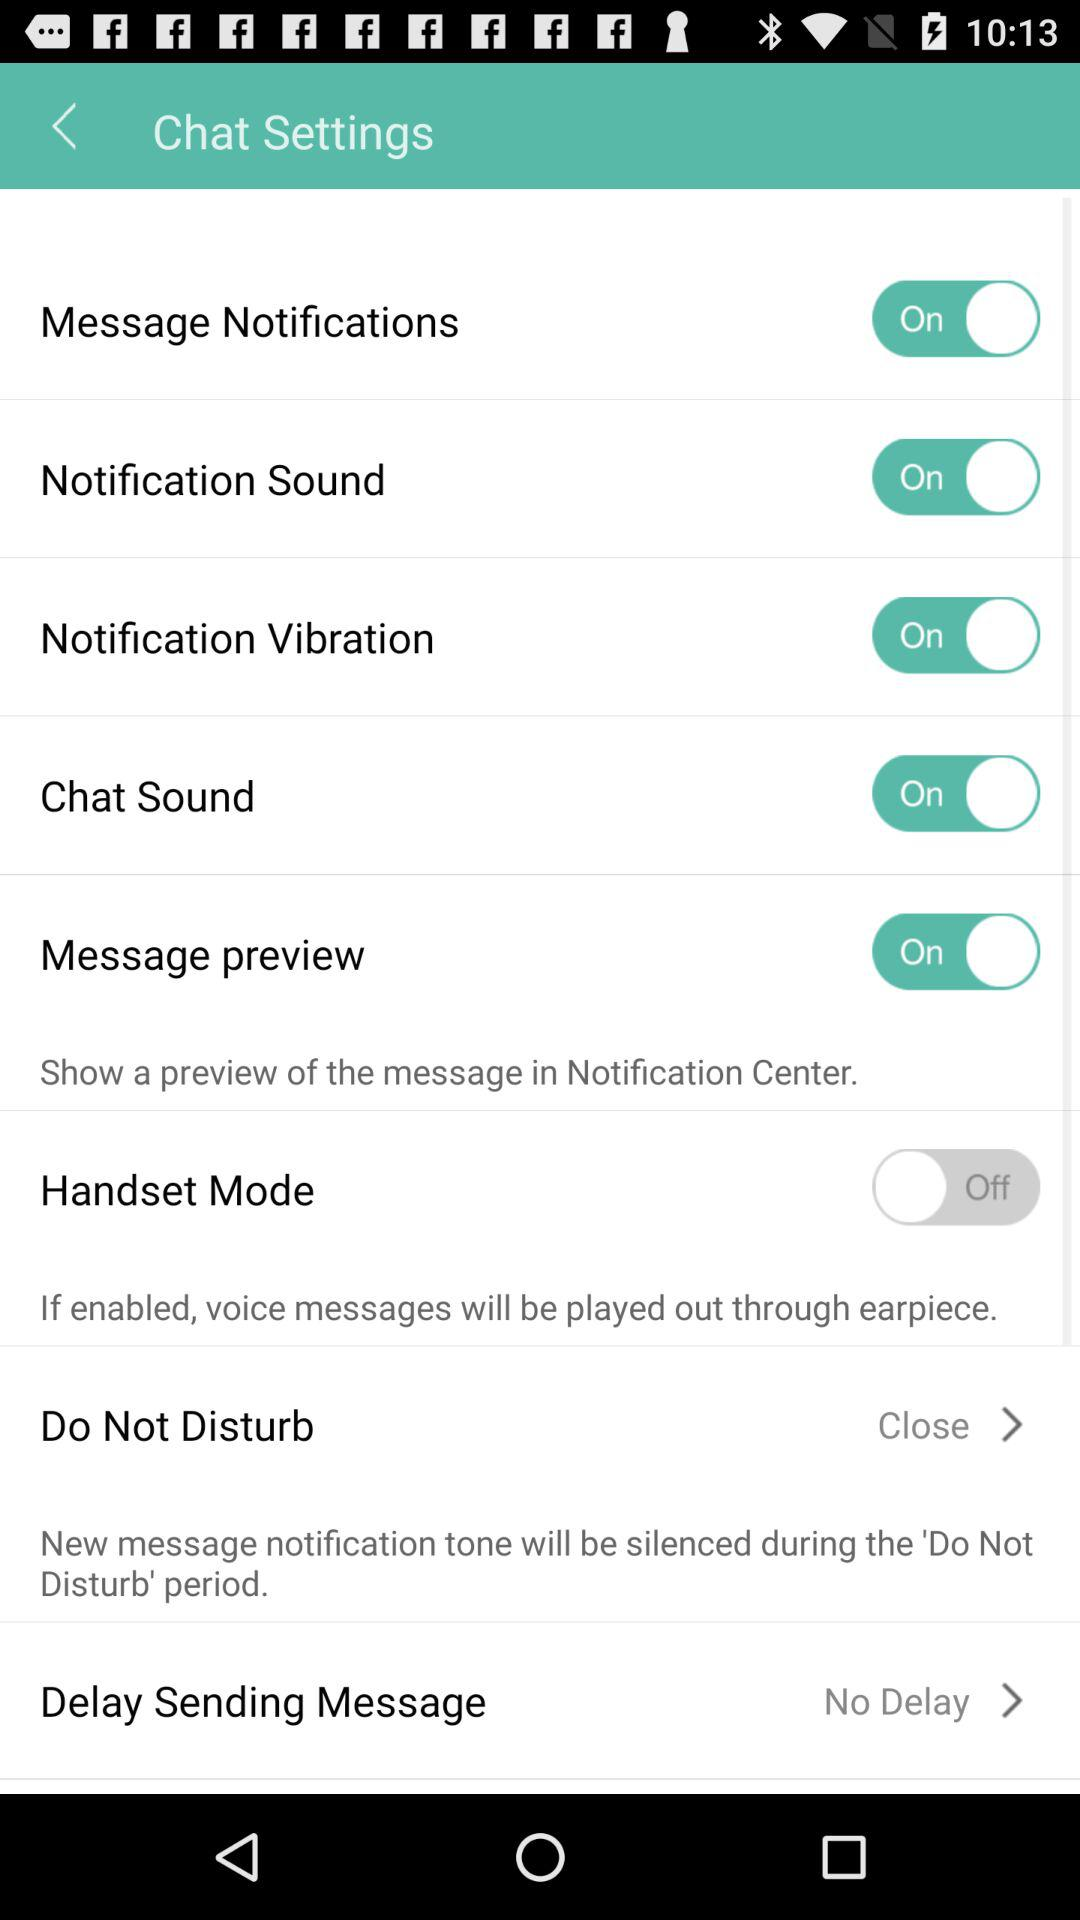What is the status of the "Handset Mode"? The status of the "Handset Mode" is "off". 